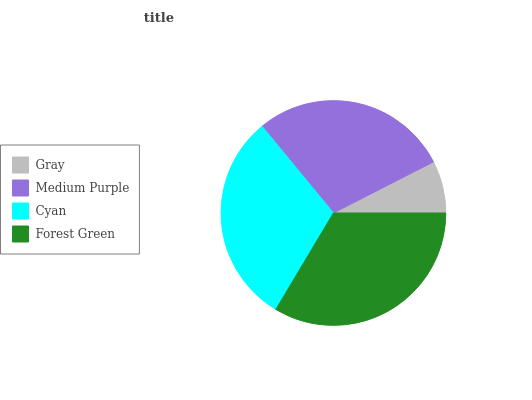Is Gray the minimum?
Answer yes or no. Yes. Is Forest Green the maximum?
Answer yes or no. Yes. Is Medium Purple the minimum?
Answer yes or no. No. Is Medium Purple the maximum?
Answer yes or no. No. Is Medium Purple greater than Gray?
Answer yes or no. Yes. Is Gray less than Medium Purple?
Answer yes or no. Yes. Is Gray greater than Medium Purple?
Answer yes or no. No. Is Medium Purple less than Gray?
Answer yes or no. No. Is Cyan the high median?
Answer yes or no. Yes. Is Medium Purple the low median?
Answer yes or no. Yes. Is Forest Green the high median?
Answer yes or no. No. Is Cyan the low median?
Answer yes or no. No. 